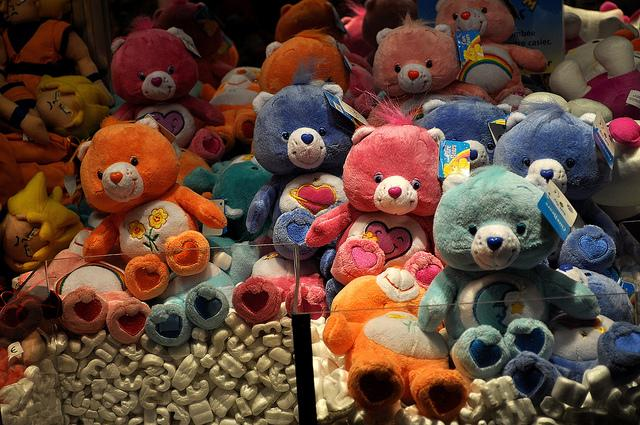What are the small white objects below the stuffed animals? packing peanuts 